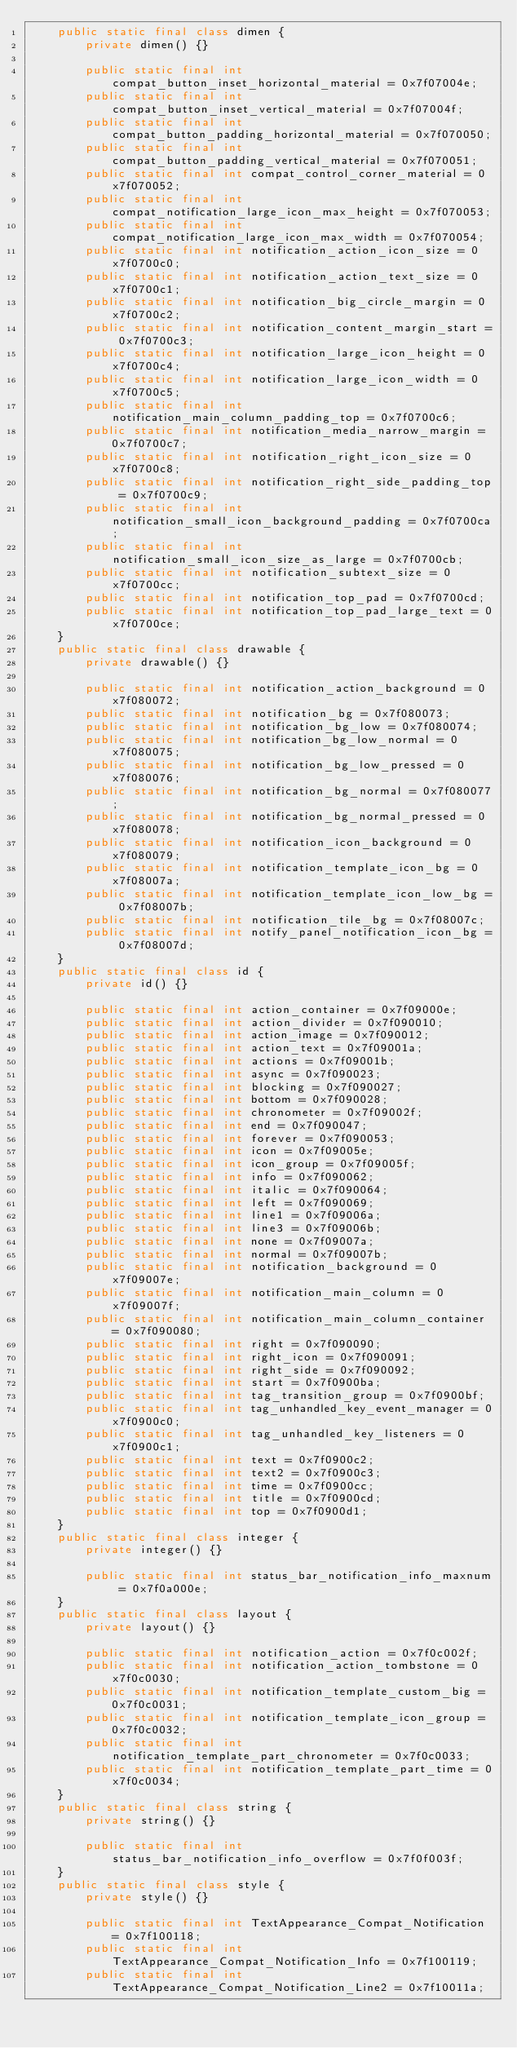Convert code to text. <code><loc_0><loc_0><loc_500><loc_500><_Java_>    public static final class dimen {
        private dimen() {}

        public static final int compat_button_inset_horizontal_material = 0x7f07004e;
        public static final int compat_button_inset_vertical_material = 0x7f07004f;
        public static final int compat_button_padding_horizontal_material = 0x7f070050;
        public static final int compat_button_padding_vertical_material = 0x7f070051;
        public static final int compat_control_corner_material = 0x7f070052;
        public static final int compat_notification_large_icon_max_height = 0x7f070053;
        public static final int compat_notification_large_icon_max_width = 0x7f070054;
        public static final int notification_action_icon_size = 0x7f0700c0;
        public static final int notification_action_text_size = 0x7f0700c1;
        public static final int notification_big_circle_margin = 0x7f0700c2;
        public static final int notification_content_margin_start = 0x7f0700c3;
        public static final int notification_large_icon_height = 0x7f0700c4;
        public static final int notification_large_icon_width = 0x7f0700c5;
        public static final int notification_main_column_padding_top = 0x7f0700c6;
        public static final int notification_media_narrow_margin = 0x7f0700c7;
        public static final int notification_right_icon_size = 0x7f0700c8;
        public static final int notification_right_side_padding_top = 0x7f0700c9;
        public static final int notification_small_icon_background_padding = 0x7f0700ca;
        public static final int notification_small_icon_size_as_large = 0x7f0700cb;
        public static final int notification_subtext_size = 0x7f0700cc;
        public static final int notification_top_pad = 0x7f0700cd;
        public static final int notification_top_pad_large_text = 0x7f0700ce;
    }
    public static final class drawable {
        private drawable() {}

        public static final int notification_action_background = 0x7f080072;
        public static final int notification_bg = 0x7f080073;
        public static final int notification_bg_low = 0x7f080074;
        public static final int notification_bg_low_normal = 0x7f080075;
        public static final int notification_bg_low_pressed = 0x7f080076;
        public static final int notification_bg_normal = 0x7f080077;
        public static final int notification_bg_normal_pressed = 0x7f080078;
        public static final int notification_icon_background = 0x7f080079;
        public static final int notification_template_icon_bg = 0x7f08007a;
        public static final int notification_template_icon_low_bg = 0x7f08007b;
        public static final int notification_tile_bg = 0x7f08007c;
        public static final int notify_panel_notification_icon_bg = 0x7f08007d;
    }
    public static final class id {
        private id() {}

        public static final int action_container = 0x7f09000e;
        public static final int action_divider = 0x7f090010;
        public static final int action_image = 0x7f090012;
        public static final int action_text = 0x7f09001a;
        public static final int actions = 0x7f09001b;
        public static final int async = 0x7f090023;
        public static final int blocking = 0x7f090027;
        public static final int bottom = 0x7f090028;
        public static final int chronometer = 0x7f09002f;
        public static final int end = 0x7f090047;
        public static final int forever = 0x7f090053;
        public static final int icon = 0x7f09005e;
        public static final int icon_group = 0x7f09005f;
        public static final int info = 0x7f090062;
        public static final int italic = 0x7f090064;
        public static final int left = 0x7f090069;
        public static final int line1 = 0x7f09006a;
        public static final int line3 = 0x7f09006b;
        public static final int none = 0x7f09007a;
        public static final int normal = 0x7f09007b;
        public static final int notification_background = 0x7f09007e;
        public static final int notification_main_column = 0x7f09007f;
        public static final int notification_main_column_container = 0x7f090080;
        public static final int right = 0x7f090090;
        public static final int right_icon = 0x7f090091;
        public static final int right_side = 0x7f090092;
        public static final int start = 0x7f0900ba;
        public static final int tag_transition_group = 0x7f0900bf;
        public static final int tag_unhandled_key_event_manager = 0x7f0900c0;
        public static final int tag_unhandled_key_listeners = 0x7f0900c1;
        public static final int text = 0x7f0900c2;
        public static final int text2 = 0x7f0900c3;
        public static final int time = 0x7f0900cc;
        public static final int title = 0x7f0900cd;
        public static final int top = 0x7f0900d1;
    }
    public static final class integer {
        private integer() {}

        public static final int status_bar_notification_info_maxnum = 0x7f0a000e;
    }
    public static final class layout {
        private layout() {}

        public static final int notification_action = 0x7f0c002f;
        public static final int notification_action_tombstone = 0x7f0c0030;
        public static final int notification_template_custom_big = 0x7f0c0031;
        public static final int notification_template_icon_group = 0x7f0c0032;
        public static final int notification_template_part_chronometer = 0x7f0c0033;
        public static final int notification_template_part_time = 0x7f0c0034;
    }
    public static final class string {
        private string() {}

        public static final int status_bar_notification_info_overflow = 0x7f0f003f;
    }
    public static final class style {
        private style() {}

        public static final int TextAppearance_Compat_Notification = 0x7f100118;
        public static final int TextAppearance_Compat_Notification_Info = 0x7f100119;
        public static final int TextAppearance_Compat_Notification_Line2 = 0x7f10011a;</code> 